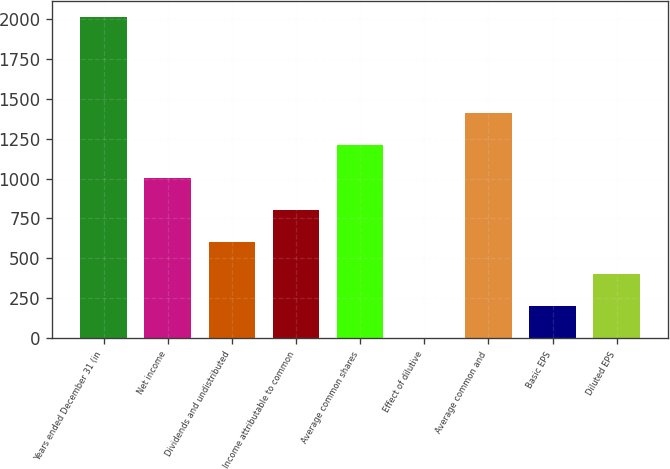Convert chart. <chart><loc_0><loc_0><loc_500><loc_500><bar_chart><fcel>Years ended December 31 (in<fcel>Net income<fcel>Dividends and undistributed<fcel>Income attributable to common<fcel>Average common shares<fcel>Effect of dilutive<fcel>Average common and<fcel>Basic EPS<fcel>Diluted EPS<nl><fcel>2012<fcel>1006.05<fcel>603.67<fcel>804.86<fcel>1207.24<fcel>0.1<fcel>1408.43<fcel>201.29<fcel>402.48<nl></chart> 